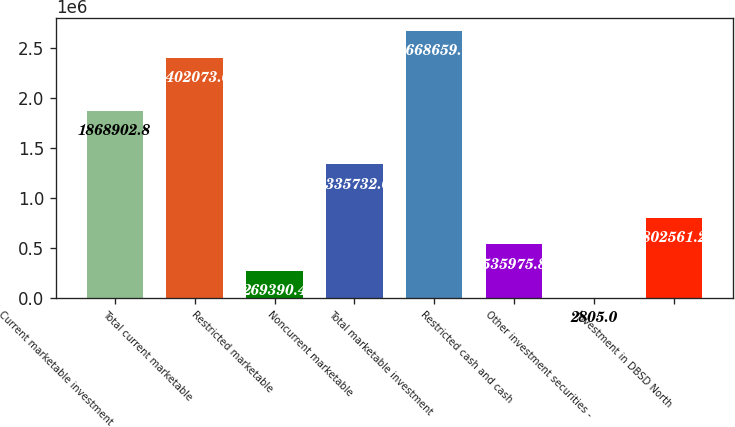Convert chart. <chart><loc_0><loc_0><loc_500><loc_500><bar_chart><fcel>Current marketable investment<fcel>Total current marketable<fcel>Restricted marketable<fcel>Noncurrent marketable<fcel>Total marketable investment<fcel>Restricted cash and cash<fcel>Other investment securities -<fcel>Investment in DBSD North<nl><fcel>1.8689e+06<fcel>2.40207e+06<fcel>269390<fcel>1.33573e+06<fcel>2.66866e+06<fcel>535976<fcel>2805<fcel>802561<nl></chart> 